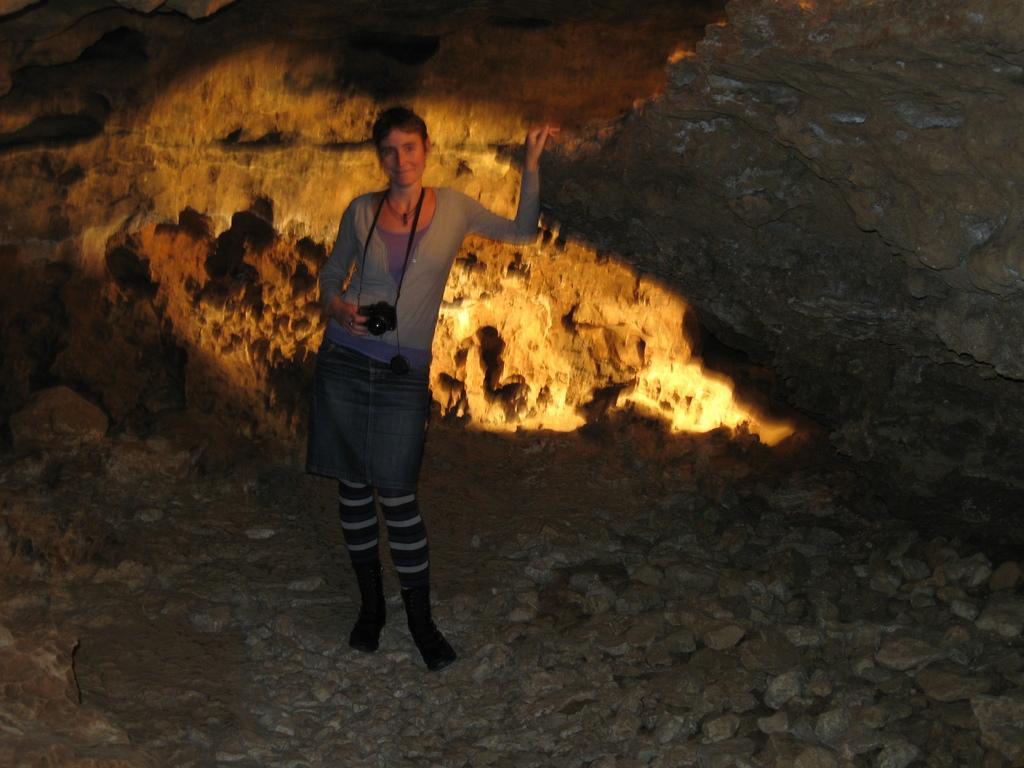Could you give a brief overview of what you see in this image? In this image we can see a woman standing on the ground holding a camera. We can also see the rock and some stones. 